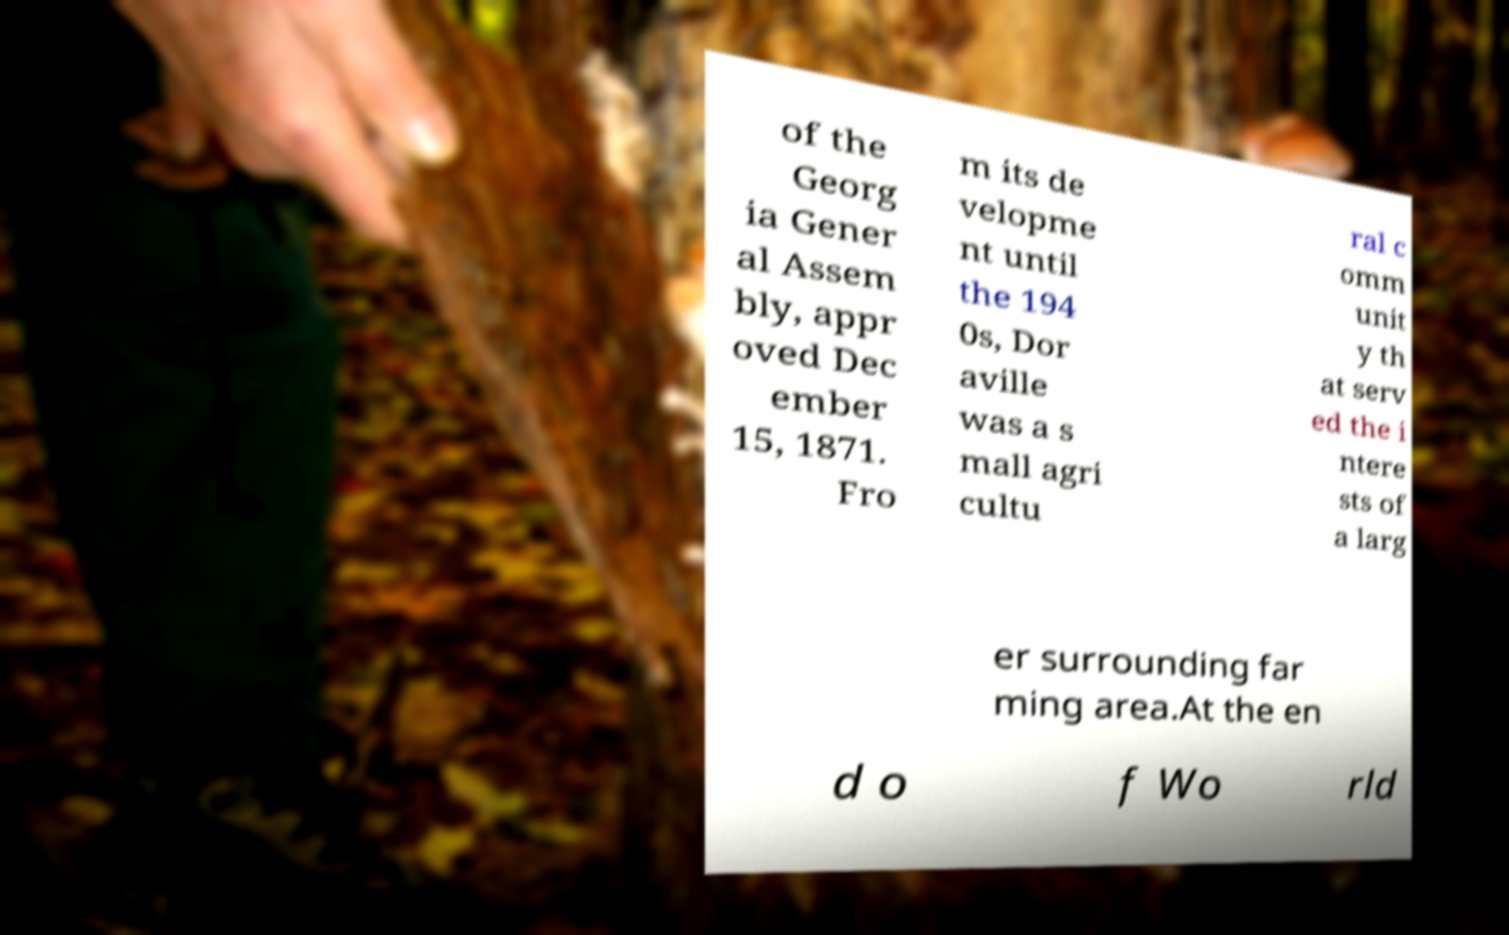Please identify and transcribe the text found in this image. of the Georg ia Gener al Assem bly, appr oved Dec ember 15, 1871. Fro m its de velopme nt until the 194 0s, Dor aville was a s mall agri cultu ral c omm unit y th at serv ed the i ntere sts of a larg er surrounding far ming area.At the en d o f Wo rld 